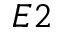Convert formula to latex. <formula><loc_0><loc_0><loc_500><loc_500>E 2</formula> 